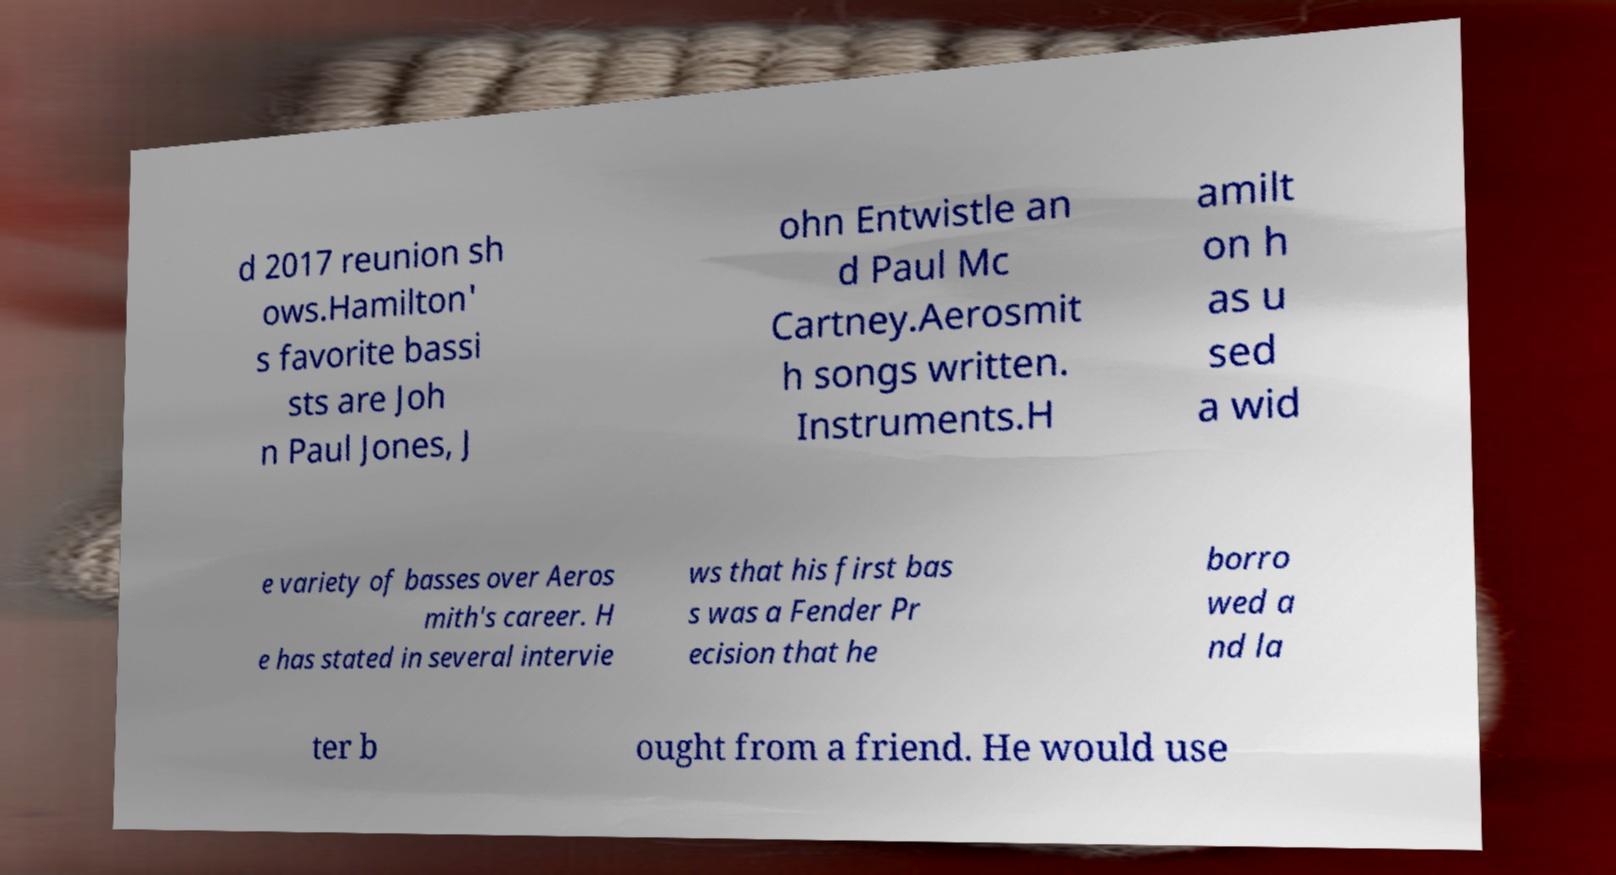Please identify and transcribe the text found in this image. d 2017 reunion sh ows.Hamilton' s favorite bassi sts are Joh n Paul Jones, J ohn Entwistle an d Paul Mc Cartney.Aerosmit h songs written. Instruments.H amilt on h as u sed a wid e variety of basses over Aeros mith's career. H e has stated in several intervie ws that his first bas s was a Fender Pr ecision that he borro wed a nd la ter b ought from a friend. He would use 